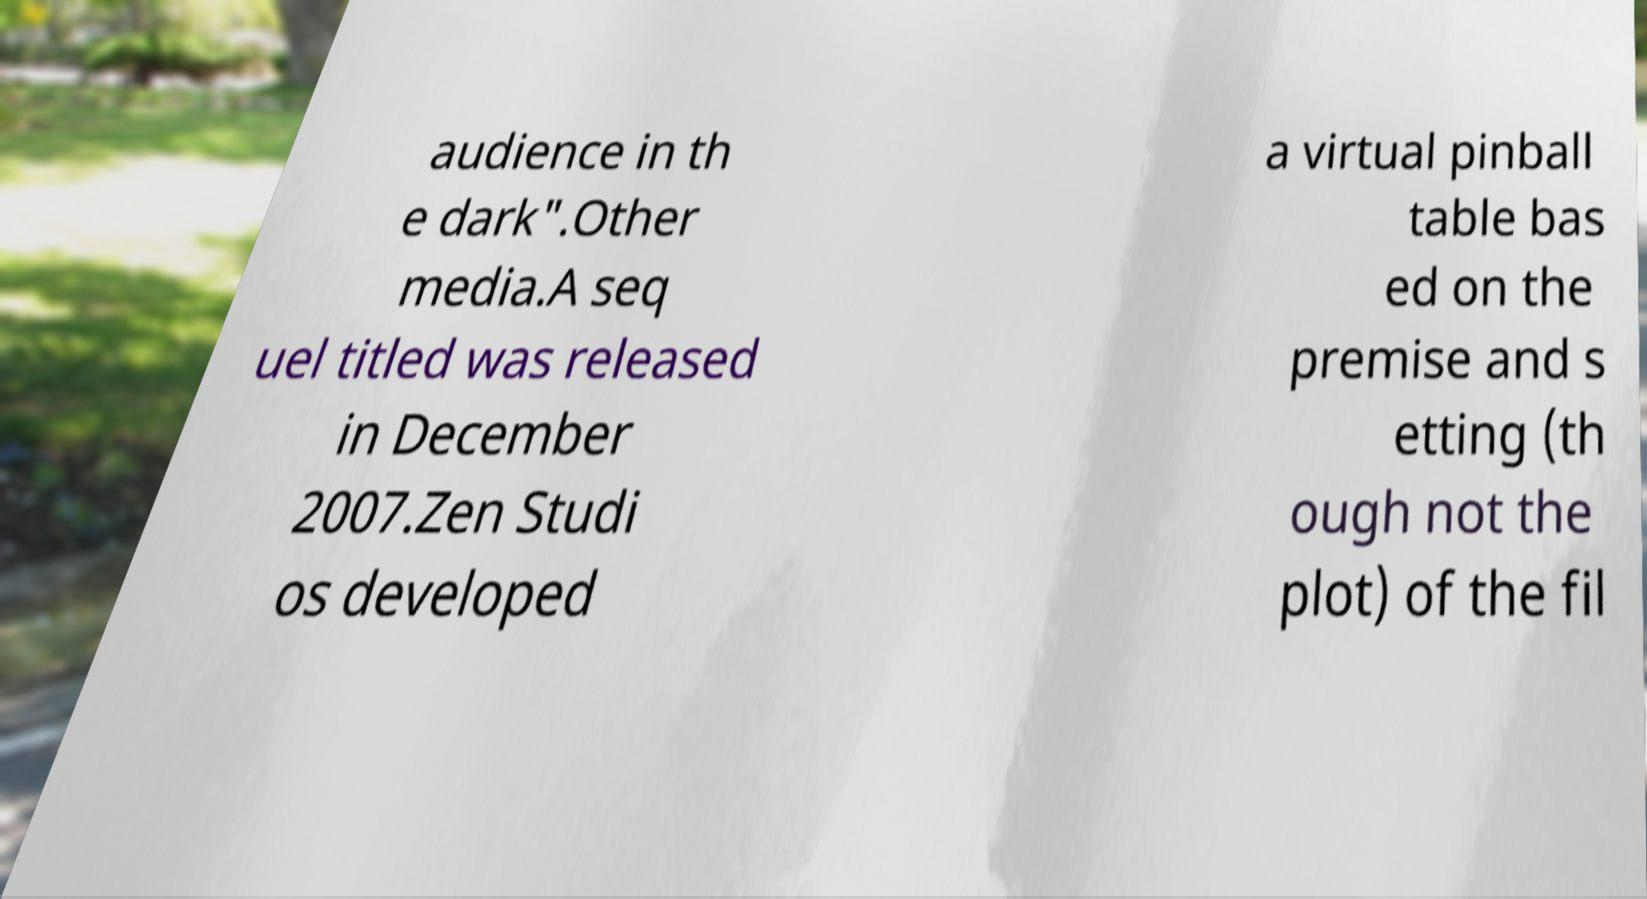Can you accurately transcribe the text from the provided image for me? audience in th e dark".Other media.A seq uel titled was released in December 2007.Zen Studi os developed a virtual pinball table bas ed on the premise and s etting (th ough not the plot) of the fil 